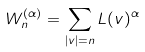<formula> <loc_0><loc_0><loc_500><loc_500>W _ { n } ^ { ( \alpha ) } = \sum _ { | v | = n } L ( v ) ^ { \alpha }</formula> 